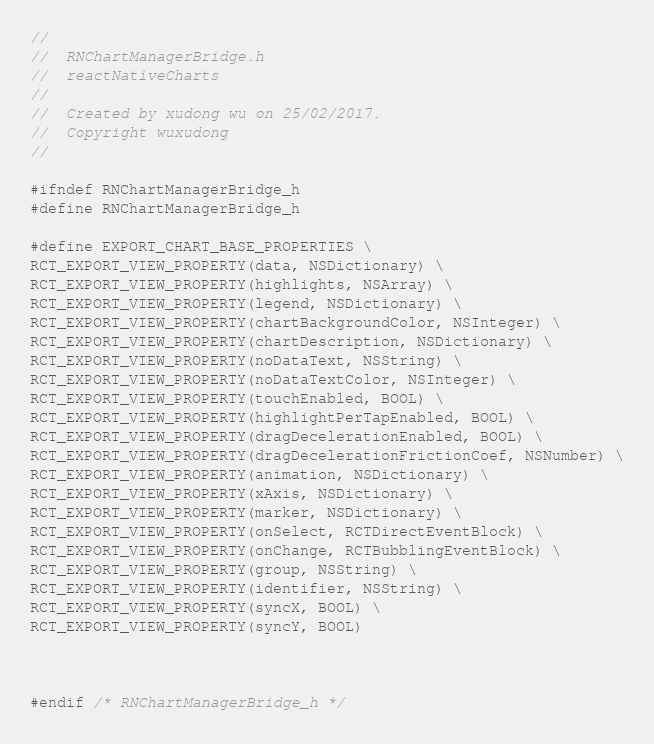<code> <loc_0><loc_0><loc_500><loc_500><_C_>//
//  RNChartManagerBridge.h
//  reactNativeCharts
//
//  Created by xudong wu on 25/02/2017.
//  Copyright wuxudong
//

#ifndef RNChartManagerBridge_h
#define RNChartManagerBridge_h

#define EXPORT_CHART_BASE_PROPERTIES \
RCT_EXPORT_VIEW_PROPERTY(data, NSDictionary) \
RCT_EXPORT_VIEW_PROPERTY(highlights, NSArray) \
RCT_EXPORT_VIEW_PROPERTY(legend, NSDictionary) \
RCT_EXPORT_VIEW_PROPERTY(chartBackgroundColor, NSInteger) \
RCT_EXPORT_VIEW_PROPERTY(chartDescription, NSDictionary) \
RCT_EXPORT_VIEW_PROPERTY(noDataText, NSString) \
RCT_EXPORT_VIEW_PROPERTY(noDataTextColor, NSInteger) \
RCT_EXPORT_VIEW_PROPERTY(touchEnabled, BOOL) \
RCT_EXPORT_VIEW_PROPERTY(highlightPerTapEnabled, BOOL) \
RCT_EXPORT_VIEW_PROPERTY(dragDecelerationEnabled, BOOL) \
RCT_EXPORT_VIEW_PROPERTY(dragDecelerationFrictionCoef, NSNumber) \
RCT_EXPORT_VIEW_PROPERTY(animation, NSDictionary) \
RCT_EXPORT_VIEW_PROPERTY(xAxis, NSDictionary) \
RCT_EXPORT_VIEW_PROPERTY(marker, NSDictionary) \
RCT_EXPORT_VIEW_PROPERTY(onSelect, RCTDirectEventBlock) \
RCT_EXPORT_VIEW_PROPERTY(onChange, RCTBubblingEventBlock) \
RCT_EXPORT_VIEW_PROPERTY(group, NSString) \
RCT_EXPORT_VIEW_PROPERTY(identifier, NSString) \
RCT_EXPORT_VIEW_PROPERTY(syncX, BOOL) \
RCT_EXPORT_VIEW_PROPERTY(syncY, BOOL)



#endif /* RNChartManagerBridge_h */
</code> 